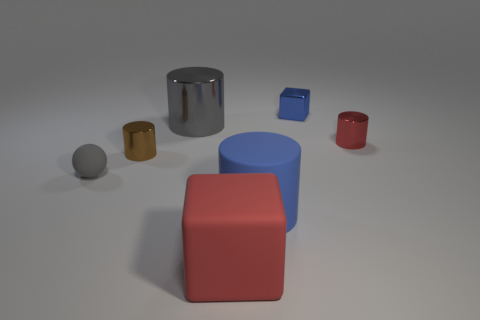There is a rubber cylinder that is the same size as the red matte block; what is its color?
Provide a succinct answer. Blue. Are there any big matte objects of the same color as the small shiny block?
Your response must be concise. Yes. What size is the red cube that is the same material as the big blue thing?
Make the answer very short. Large. What size is the object that is the same color as the big matte block?
Keep it short and to the point. Small. What number of other things are the same size as the red metal thing?
Provide a succinct answer. 3. What is the red object that is in front of the gray rubber thing made of?
Your answer should be very brief. Rubber. What shape is the blue thing that is behind the rubber object behind the big cylinder that is in front of the brown metal object?
Make the answer very short. Cube. Is the blue matte cylinder the same size as the red matte block?
Keep it short and to the point. Yes. How many objects are purple cylinders or tiny things that are to the left of the blue block?
Ensure brevity in your answer.  2. How many objects are objects behind the large cube or big cylinders that are in front of the gray cylinder?
Ensure brevity in your answer.  6. 